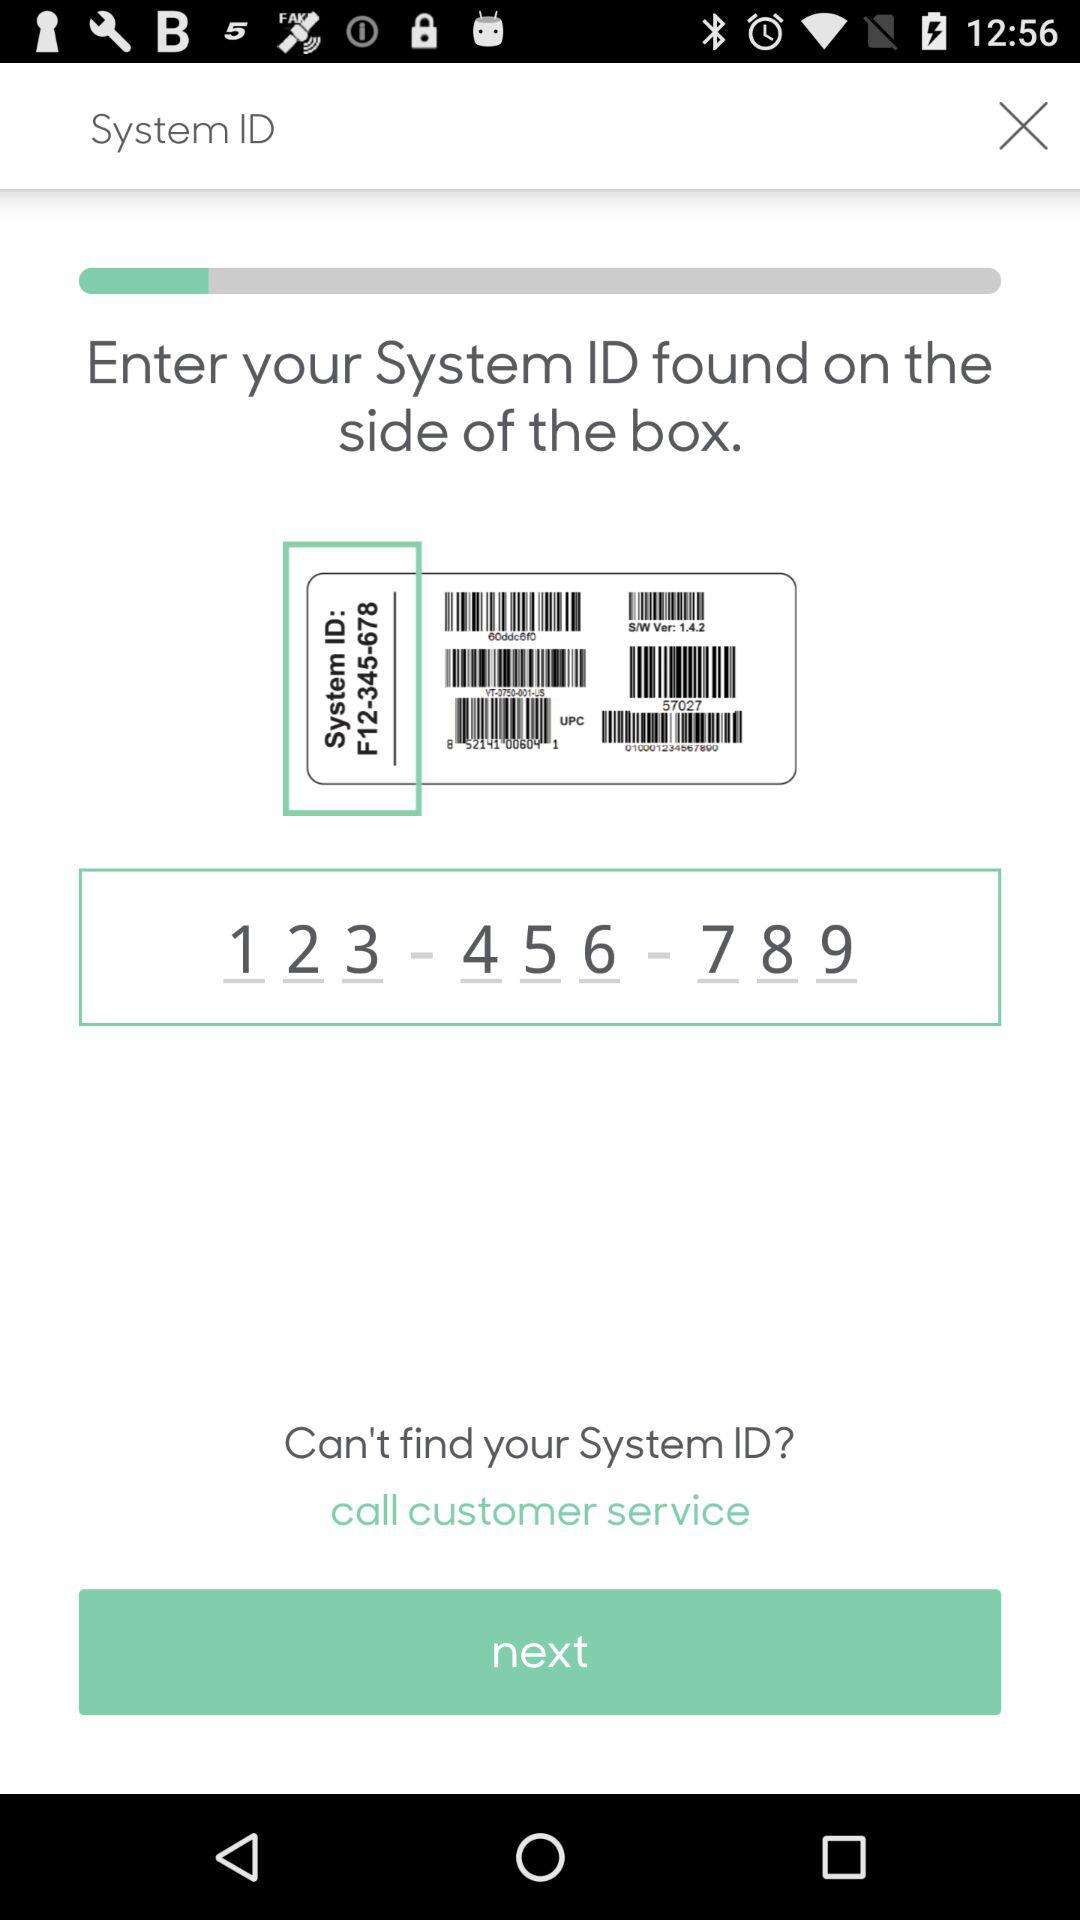What is the system ID? The system ID is F12-345-678. 